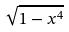Convert formula to latex. <formula><loc_0><loc_0><loc_500><loc_500>\sqrt { 1 - x ^ { 4 } }</formula> 